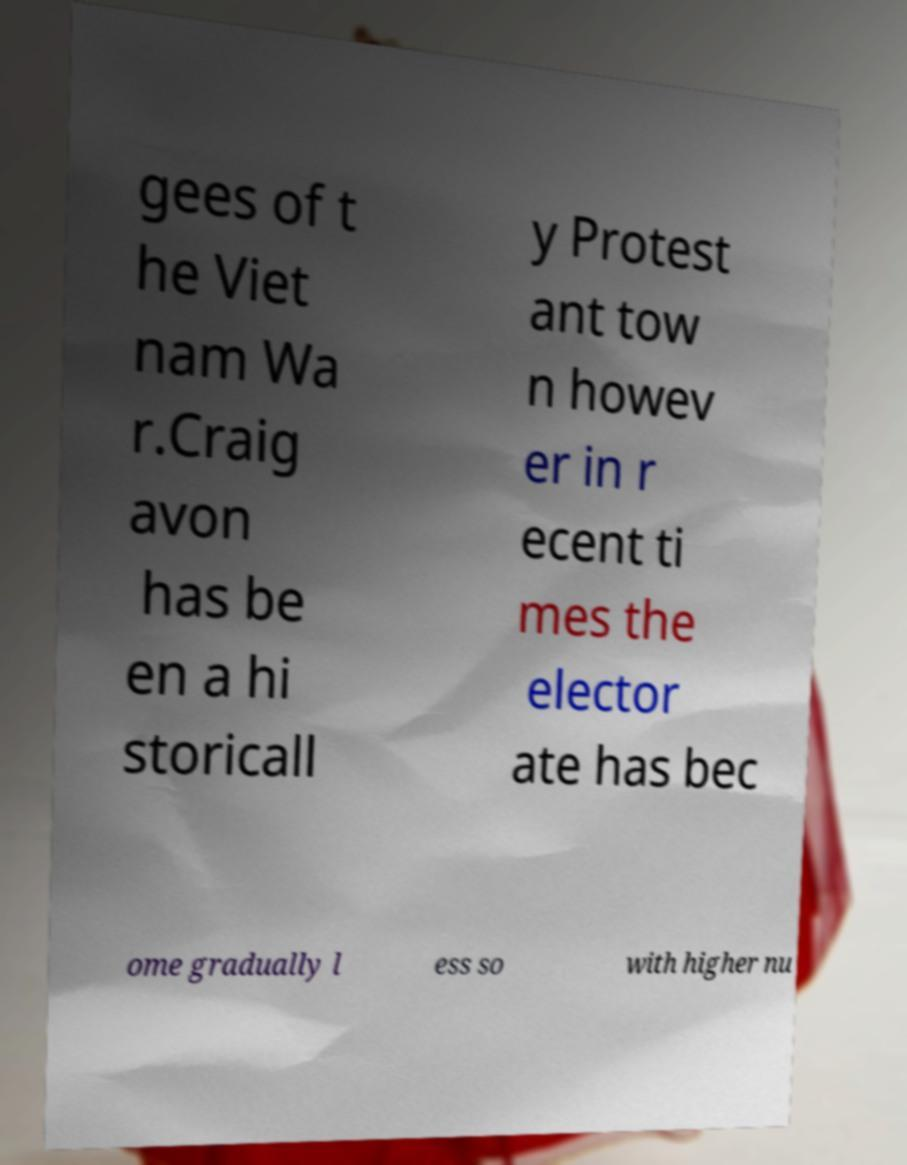There's text embedded in this image that I need extracted. Can you transcribe it verbatim? gees of t he Viet nam Wa r.Craig avon has be en a hi storicall y Protest ant tow n howev er in r ecent ti mes the elector ate has bec ome gradually l ess so with higher nu 